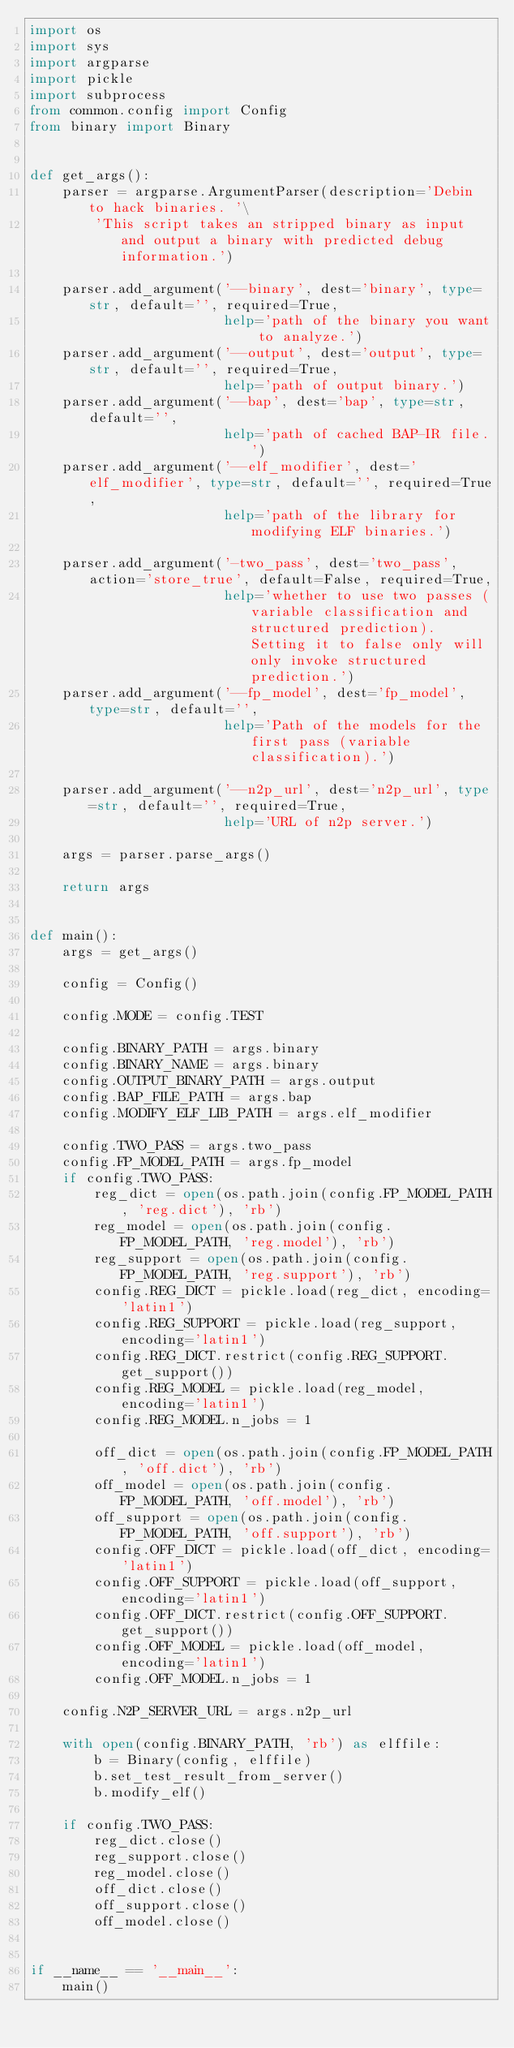Convert code to text. <code><loc_0><loc_0><loc_500><loc_500><_Python_>import os
import sys
import argparse
import pickle
import subprocess
from common.config import Config
from binary import Binary


def get_args():
    parser = argparse.ArgumentParser(description='Debin to hack binaries. '\
        'This script takes an stripped binary as input and output a binary with predicted debug information.')

    parser.add_argument('--binary', dest='binary', type=str, default='', required=True,
                        help='path of the binary you want to analyze.')
    parser.add_argument('--output', dest='output', type=str, default='', required=True,
                        help='path of output binary.')
    parser.add_argument('--bap', dest='bap', type=str, default='',
                        help='path of cached BAP-IR file.')
    parser.add_argument('--elf_modifier', dest='elf_modifier', type=str, default='', required=True,
                        help='path of the library for modifying ELF binaries.')

    parser.add_argument('-two_pass', dest='two_pass', action='store_true', default=False, required=True,
                        help='whether to use two passes (variable classification and structured prediction). Setting it to false only will only invoke structured prediction.')
    parser.add_argument('--fp_model', dest='fp_model', type=str, default='',
                        help='Path of the models for the first pass (variable classification).')

    parser.add_argument('--n2p_url', dest='n2p_url', type=str, default='', required=True,
                        help='URL of n2p server.')

    args = parser.parse_args()

    return args


def main():
    args = get_args()

    config = Config()

    config.MODE = config.TEST

    config.BINARY_PATH = args.binary
    config.BINARY_NAME = args.binary
    config.OUTPUT_BINARY_PATH = args.output
    config.BAP_FILE_PATH = args.bap
    config.MODIFY_ELF_LIB_PATH = args.elf_modifier

    config.TWO_PASS = args.two_pass
    config.FP_MODEL_PATH = args.fp_model
    if config.TWO_PASS:
        reg_dict = open(os.path.join(config.FP_MODEL_PATH, 'reg.dict'), 'rb')
        reg_model = open(os.path.join(config.FP_MODEL_PATH, 'reg.model'), 'rb')
        reg_support = open(os.path.join(config.FP_MODEL_PATH, 'reg.support'), 'rb')
        config.REG_DICT = pickle.load(reg_dict, encoding='latin1')
        config.REG_SUPPORT = pickle.load(reg_support, encoding='latin1')
        config.REG_DICT.restrict(config.REG_SUPPORT.get_support())
        config.REG_MODEL = pickle.load(reg_model, encoding='latin1')
        config.REG_MODEL.n_jobs = 1

        off_dict = open(os.path.join(config.FP_MODEL_PATH, 'off.dict'), 'rb')
        off_model = open(os.path.join(config.FP_MODEL_PATH, 'off.model'), 'rb')
        off_support = open(os.path.join(config.FP_MODEL_PATH, 'off.support'), 'rb')
        config.OFF_DICT = pickle.load(off_dict, encoding='latin1')
        config.OFF_SUPPORT = pickle.load(off_support, encoding='latin1')
        config.OFF_DICT.restrict(config.OFF_SUPPORT.get_support())
        config.OFF_MODEL = pickle.load(off_model, encoding='latin1')
        config.OFF_MODEL.n_jobs = 1

    config.N2P_SERVER_URL = args.n2p_url

    with open(config.BINARY_PATH, 'rb') as elffile:
        b = Binary(config, elffile)
        b.set_test_result_from_server()
        b.modify_elf()

    if config.TWO_PASS:
        reg_dict.close()
        reg_support.close()
        reg_model.close()
        off_dict.close()
        off_support.close()
        off_model.close()


if __name__ == '__main__':
    main()</code> 